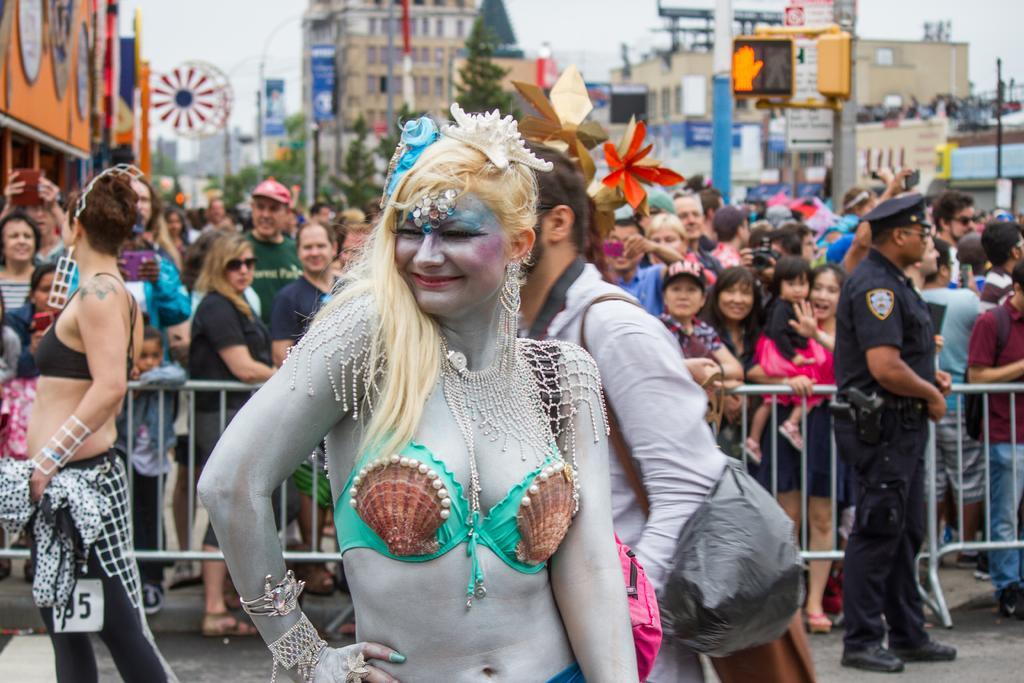How would you summarize this image in a sentence or two? In the center of the image we can see a lady standing and smiling. She is wearing a costume and we can see a painting on her. In the background there are people, fence, buildings, trees, poles and sky. 